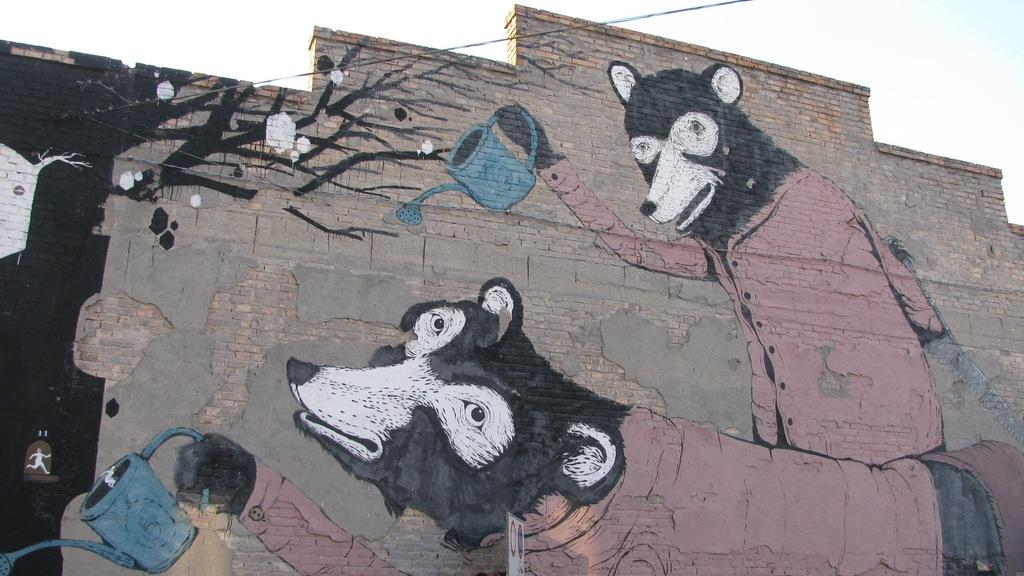What is present on the wall in the image? There is a painting on the wall in the image. What is the subject of the painting? The painting depicts foxes. What are the foxes in the painting holding? The foxes in the painting are holding water buckets. What is visible at the top of the image? The sky is visible at the top of the image. What can be seen in the sky? Clouds are present in the sky. How many fingers can be seen on the foxes in the painting? There are no fingers visible on the foxes in the painting, as they are depicted as animals and not humans. What type of railway is present in the image? There is no railway present in the image; it features a painting of foxes holding water buckets on a wall. 